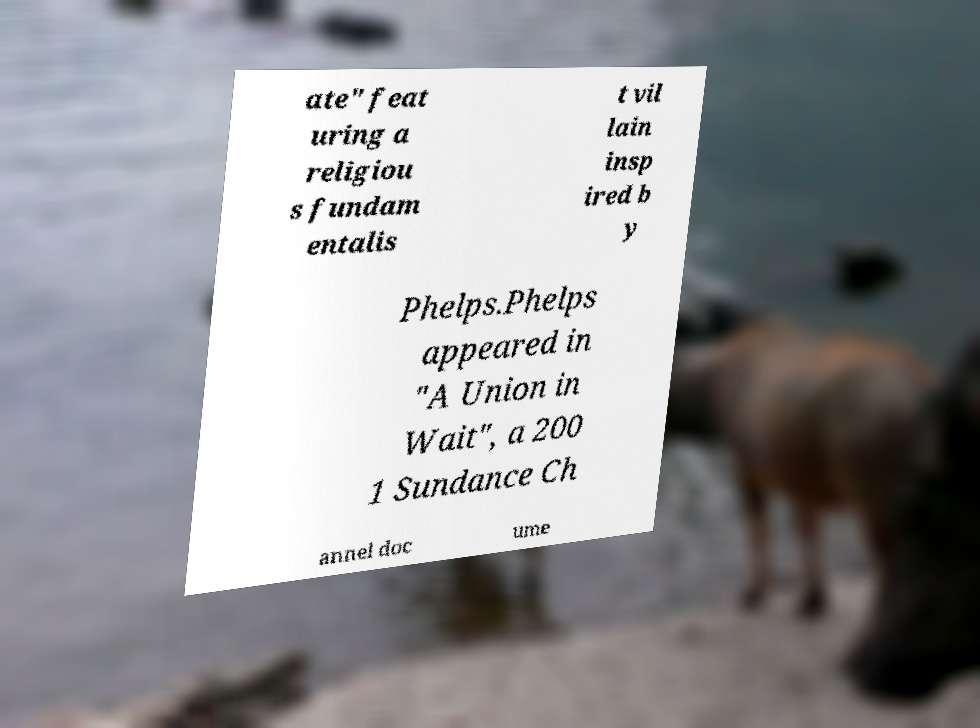What messages or text are displayed in this image? I need them in a readable, typed format. ate" feat uring a religiou s fundam entalis t vil lain insp ired b y Phelps.Phelps appeared in "A Union in Wait", a 200 1 Sundance Ch annel doc ume 